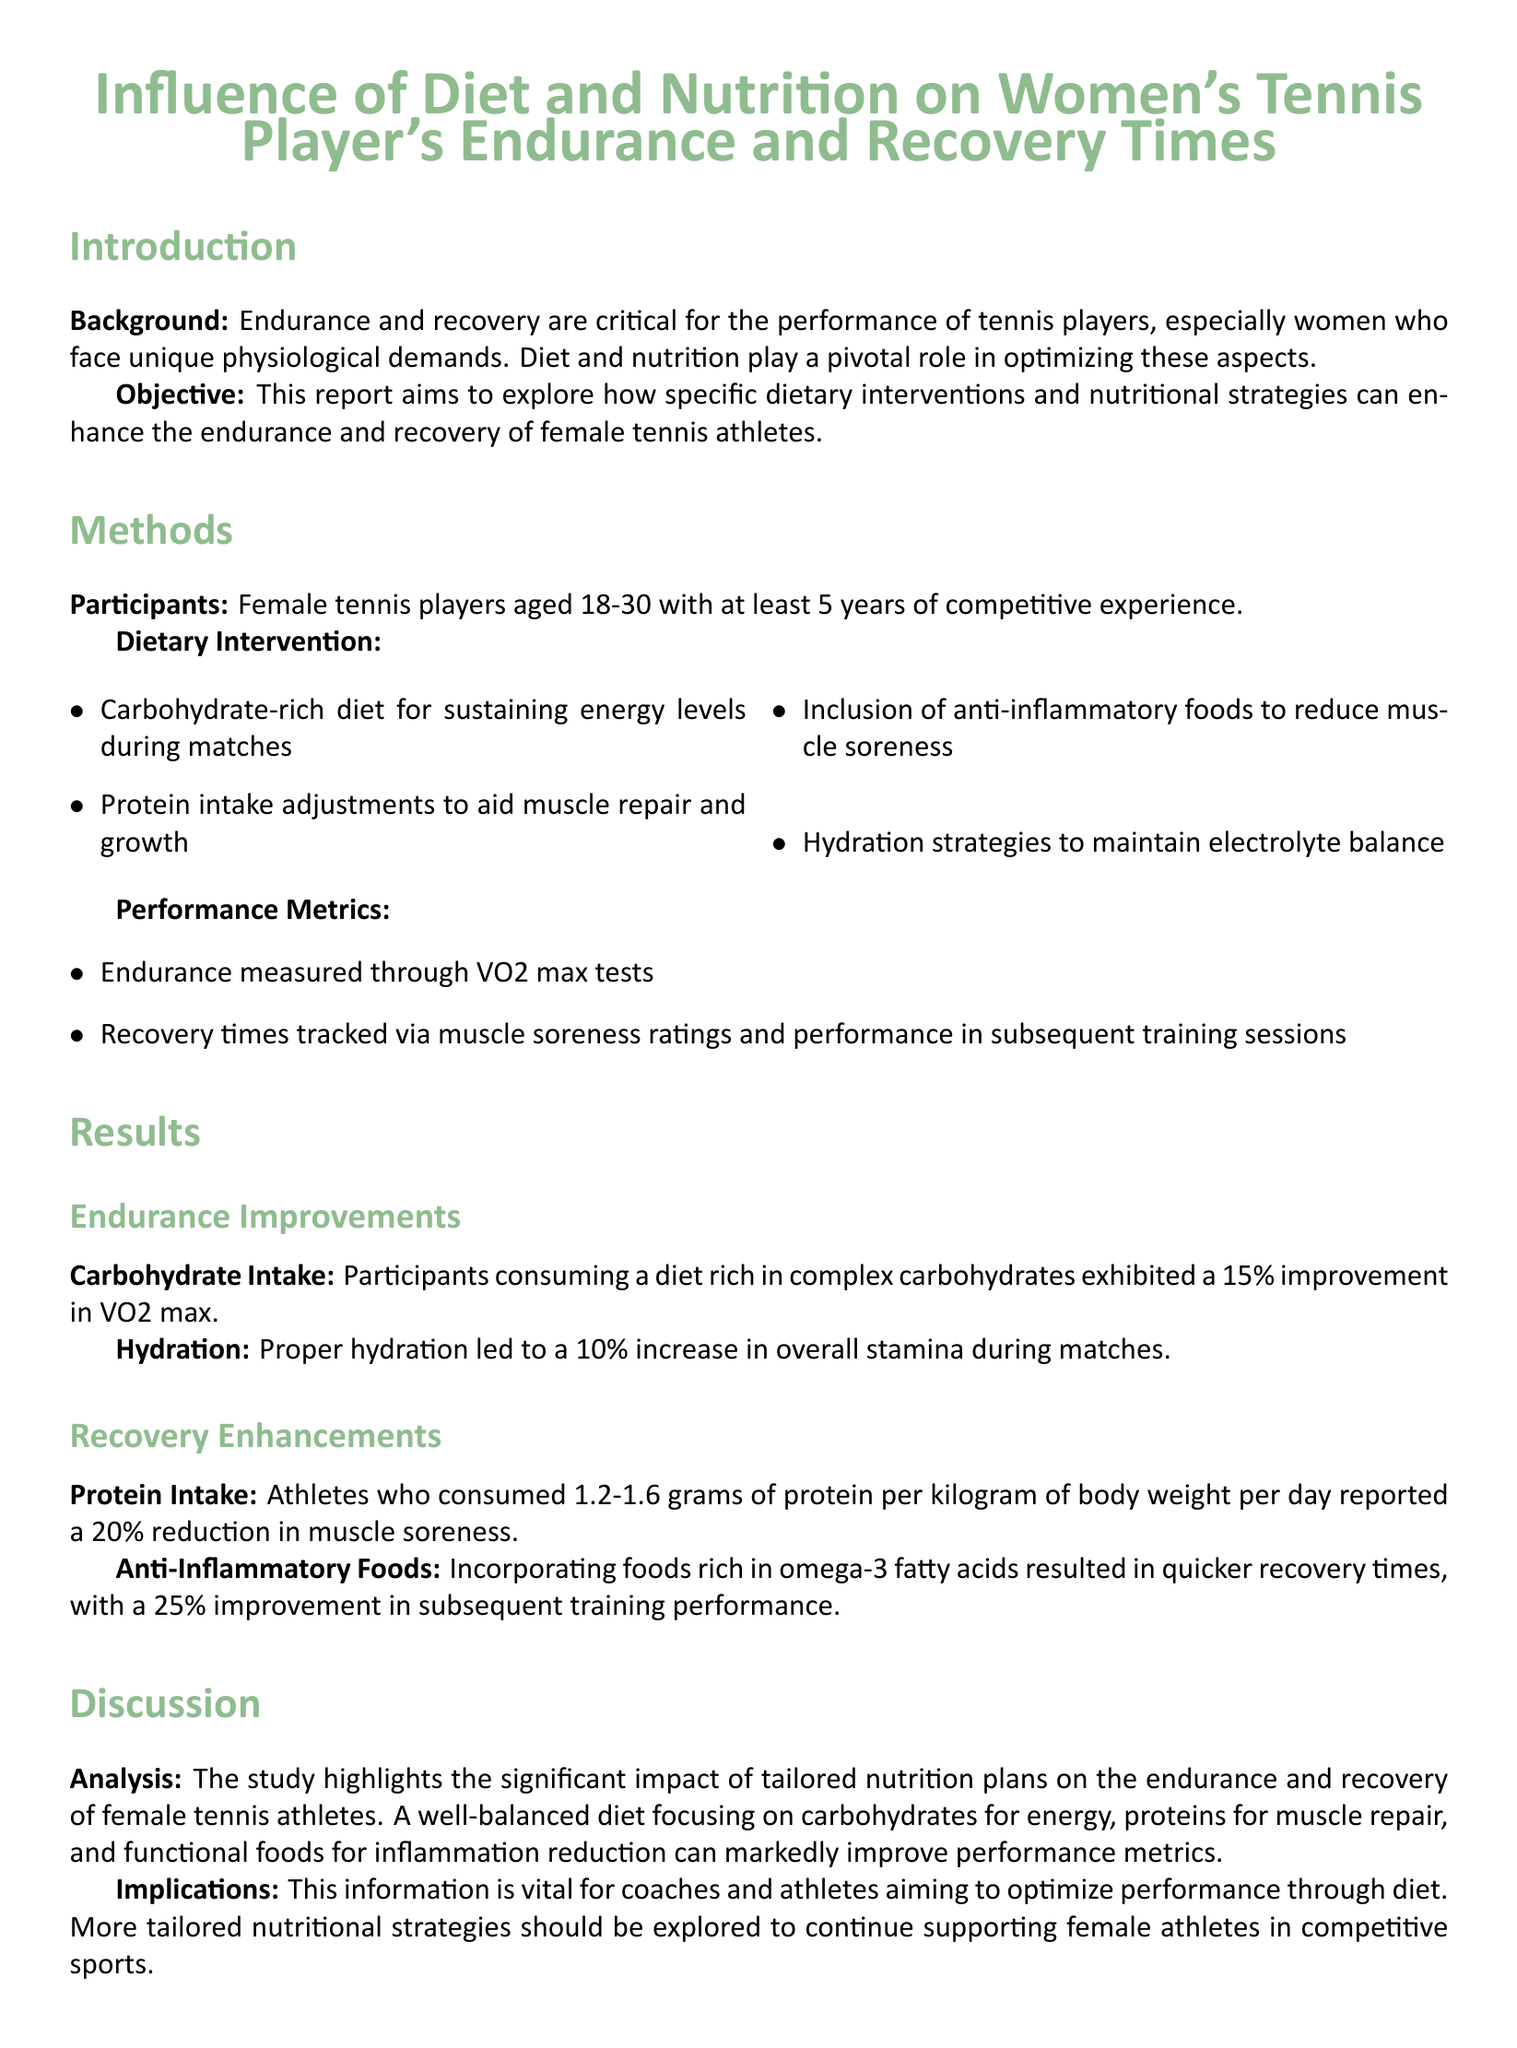What is the age range of participants? The document states that participants are female tennis players aged 18-30.
Answer: 18-30 What is the primary purpose of this report? The objective highlights the aim to explore how dietary interventions enhance endurance and recovery of female tennis athletes.
Answer: To explore dietary interventions What percentage improvement in VO2 max was noted with carbohydrate intake? The endurance results indicate a 15% improvement in VO2 max with carbohydrate-rich diets.
Answer: 15% How much protein should athletes consume per kilogram of body weight? The report specifies that athletes should consume 1.2-1.6 grams of protein per kilogram of body weight.
Answer: 1.2-1.6 grams What was the recovery time improvement percentage due to anti-inflammatory foods? The results highlighted a 25% improvement in recovery times with anti-inflammatory foods.
Answer: 25% What hydration strategy is mentioned for female tennis players? The dietary intervention discusses hydration strategies to maintain electrolyte balance.
Answer: Maintain electrolyte balance What factor is linked to a 10% increase in stamina? The document associates proper hydration with a 10% increase in overall stamina during matches.
Answer: Proper hydration What type of foods were recommended to reduce muscle soreness? The dietary intervention recommends the inclusion of anti-inflammatory foods to reduce muscle soreness.
Answer: Anti-inflammatory foods 